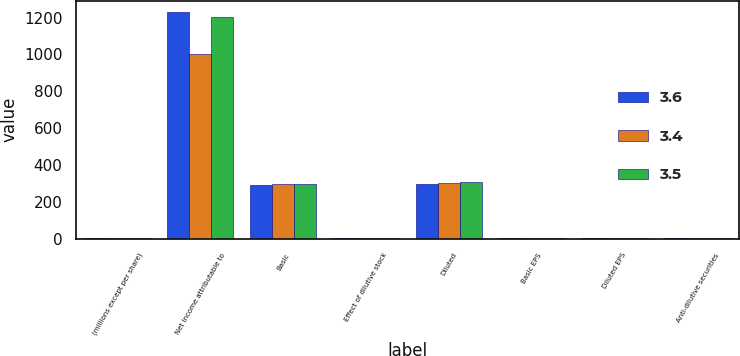<chart> <loc_0><loc_0><loc_500><loc_500><stacked_bar_chart><ecel><fcel>(millions except per share)<fcel>Net income attributable to<fcel>Basic<fcel>Effect of dilutive stock<fcel>Diluted<fcel>Basic EPS<fcel>Diluted EPS<fcel>Anti-dilutive securities<nl><fcel>3.6<fcel>5<fcel>1229.6<fcel>292.5<fcel>4.2<fcel>296.7<fcel>4.2<fcel>4.14<fcel>3.6<nl><fcel>3.4<fcel>5<fcel>1002.1<fcel>296.4<fcel>5<fcel>301.4<fcel>3.38<fcel>3.32<fcel>3.5<nl><fcel>3.5<fcel>5<fcel>1202.8<fcel>300.1<fcel>5.8<fcel>305.9<fcel>4.01<fcel>3.93<fcel>3.4<nl></chart> 